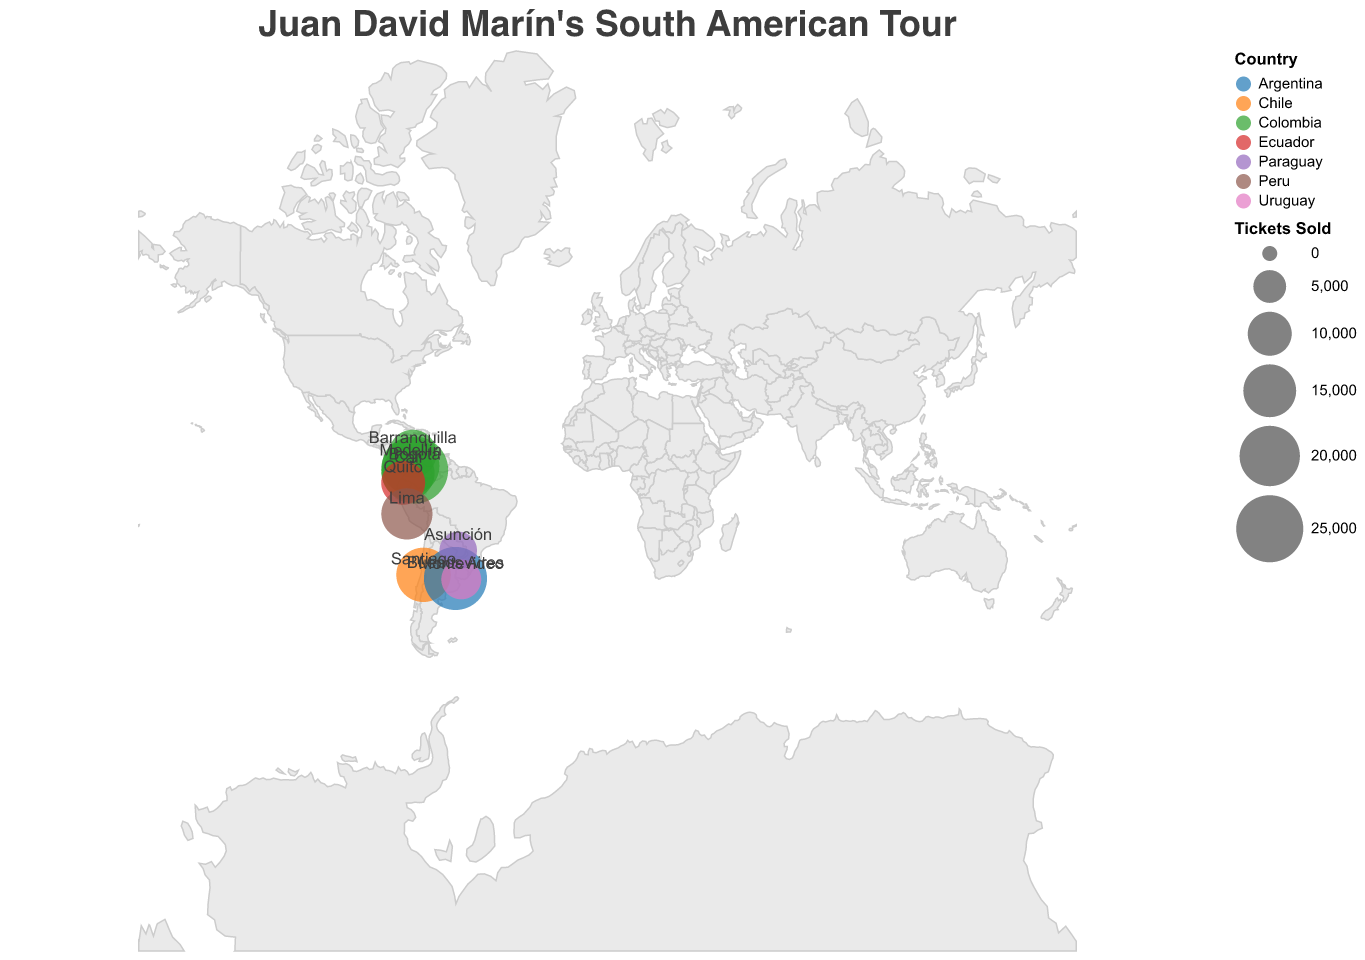What is the title of the map? The title of the map can be found at the top, which describes the purpose of the geographical representation.
Answer: Juan David Marín's South American Tour What city had the highest number of tickets sold? By comparing the sizes of the circles, the city with the largest circle represents the highest number of tickets sold.
Answer: Bogotá Which country has the most cities represented on the map? Identify the number of cities listed for each country and compare them. Colombia has the most cities.
Answer: Colombia How many tickets were sold in total across all cities? Sum the tickets sold in each city: 25,000 + 18,000 + 15,000 + 12,000 + 10,000 + 14,000 + 16,000 + 22,000 + 8,000 + 7,000 = 147,000.
Answer: 147,000 Which city in Colombia had the least tickets sold? Identify and compare the tickets sold in all the Colombian cities on the map. Barranquilla had the least.
Answer: Barranquilla How do the ticket sales in Buenos Aires compare to those in Santiago? Compare the circle sizes for Buenos Aires and Santiago; Buenos Aires has a larger circle, indicating more tickets sold.
Answer: Buenos Aires sold more tickets than Santiago What is the average number of tickets sold in Colombian cities? Calculate the total tickets sold in Colombian cities (25,000 + 18,000 + 15,000 + 12,000) = 70,000 and divide by the number of cities (4). 70,000 / 4 = 17,500.
Answer: 17,500 Which city has the highest venue capacity, and how does it compare with its tickets sold? Compare the venue capacities to find the highest one (Bogotá with 30,000), and then check the tickets sold (25,000). Bogotá sold 5,000 fewer tickets than its capacity.
Answer: Bogotá; 5,000 fewer What is the ratio of tickets sold to venue capacity in Quito? Divide the number of tickets sold by the venue capacity in Quito: 10,000 / 12,000 = 0.8333.
Answer: 0.8333 Which city is closest to Lima in terms of geographic coordinates? Locate Lima on the map by its latitude and longitude (-12.0464, -77.0428) and find the closest city geographically. Quito is closest.
Answer: Quito 